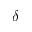Convert formula to latex. <formula><loc_0><loc_0><loc_500><loc_500>\delta</formula> 